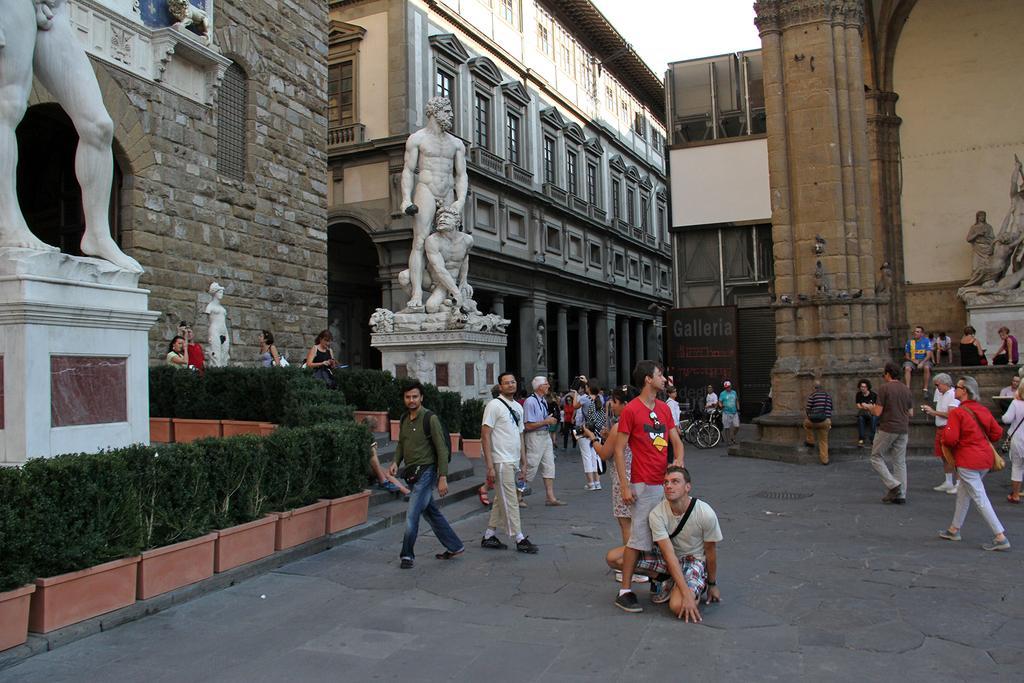Could you give a brief overview of what you see in this image? In this image we can see people are walking on the road. In the background, we can see sculptures, plants, boards and buildings. 